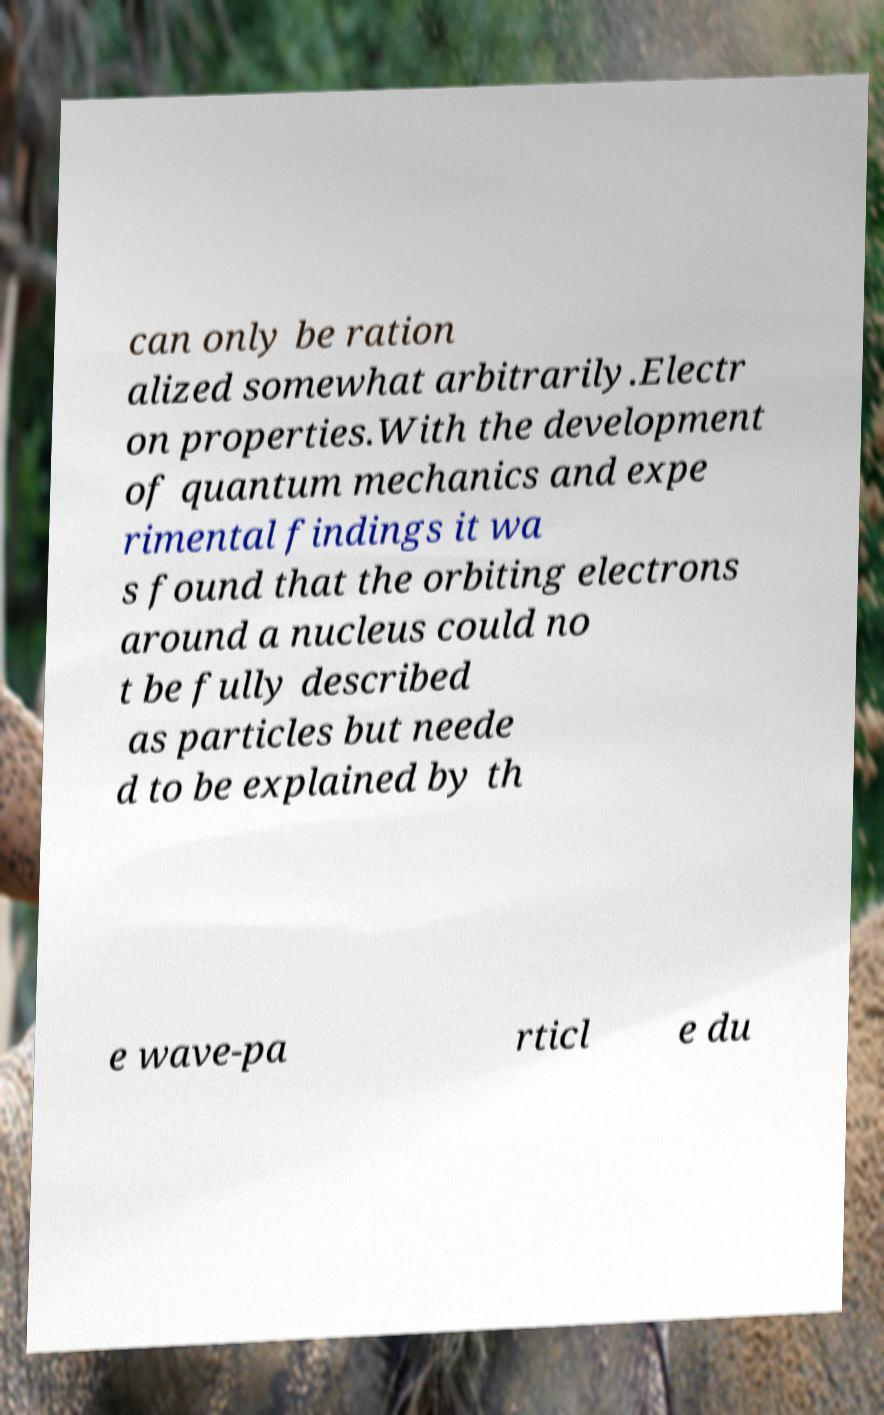Could you assist in decoding the text presented in this image and type it out clearly? can only be ration alized somewhat arbitrarily.Electr on properties.With the development of quantum mechanics and expe rimental findings it wa s found that the orbiting electrons around a nucleus could no t be fully described as particles but neede d to be explained by th e wave-pa rticl e du 